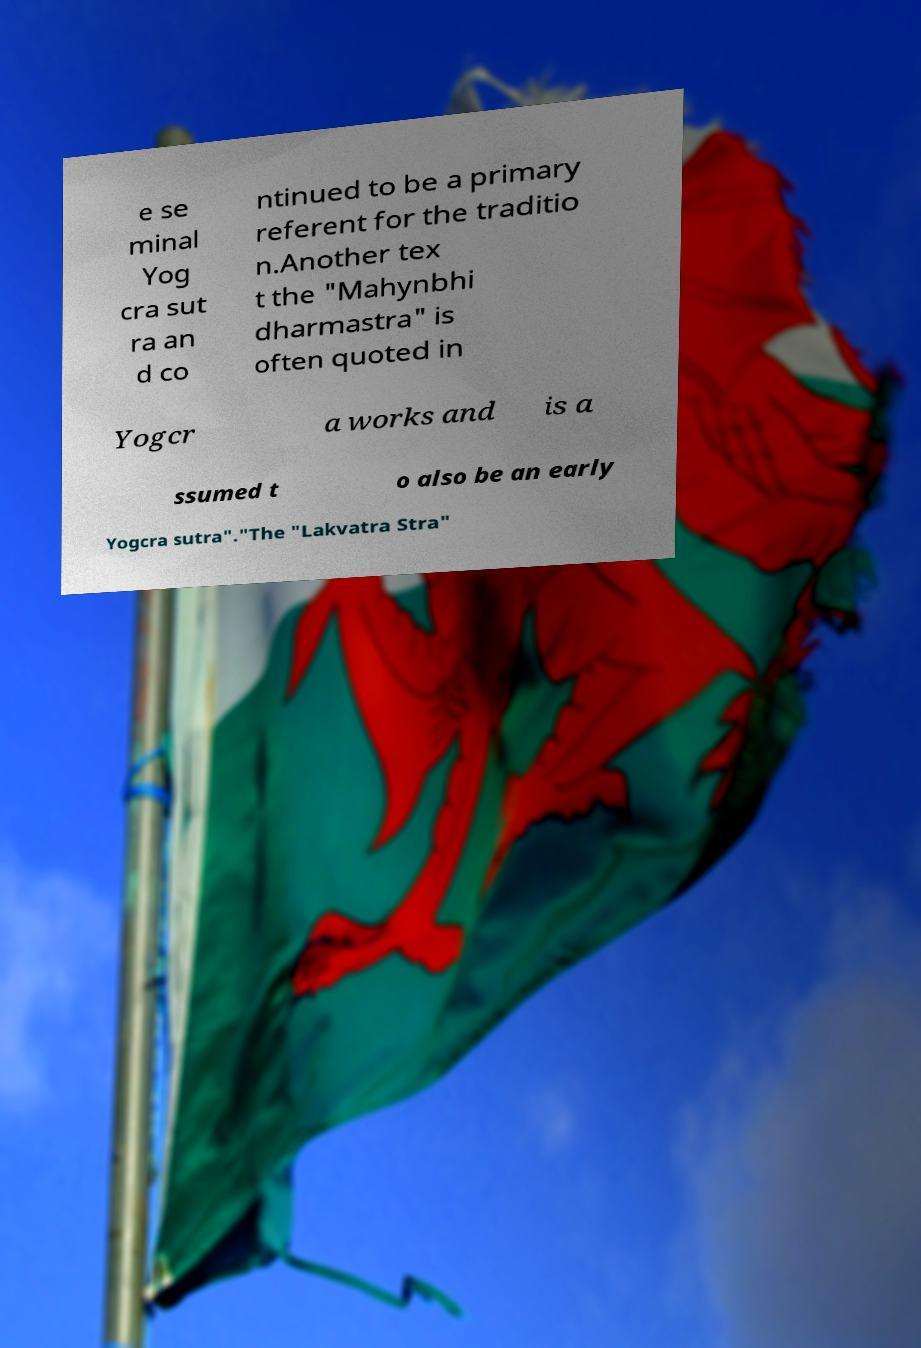Could you extract and type out the text from this image? e se minal Yog cra sut ra an d co ntinued to be a primary referent for the traditio n.Another tex t the "Mahynbhi dharmastra" is often quoted in Yogcr a works and is a ssumed t o also be an early Yogcra sutra"."The "Lakvatra Stra" 